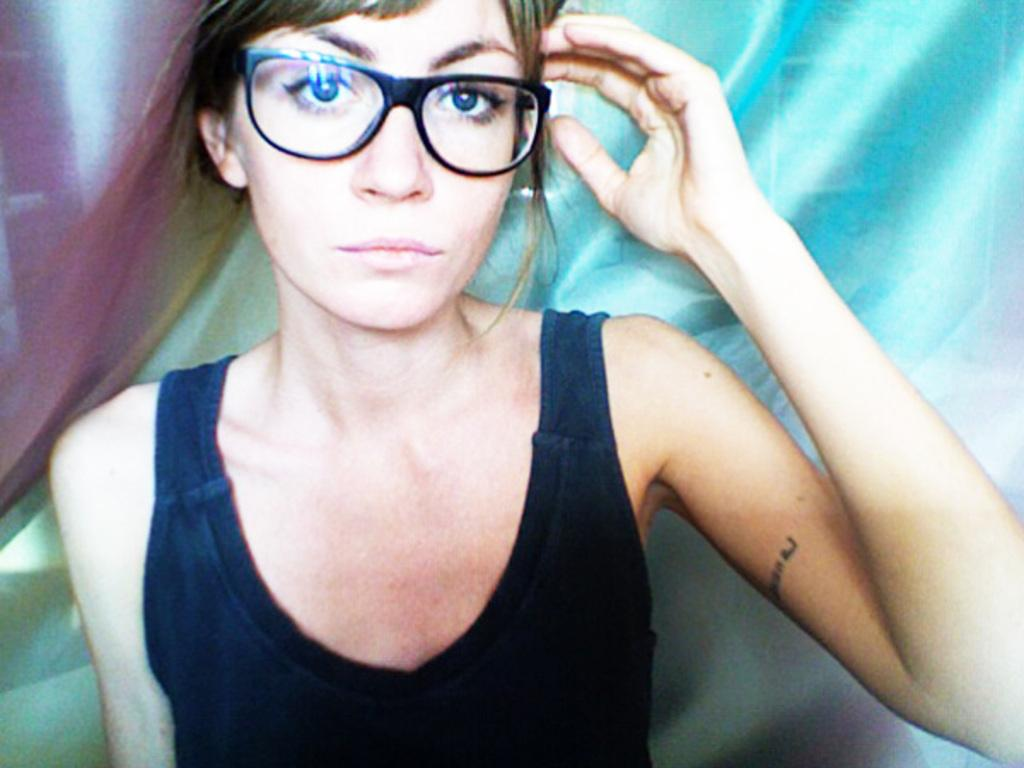What is the main subject of the image? There is a person in the center of the image. What is the person wearing on their upper body? The person is wearing a black top. Are there any accessories visible on the person? Yes, the person is wearing glasses. How would you describe the background of the image? The background of the image is blurred. What type of glass is being used to create shade in the image? There is no glass or shade present in the image; it features a person wearing glasses and a blurred background. 